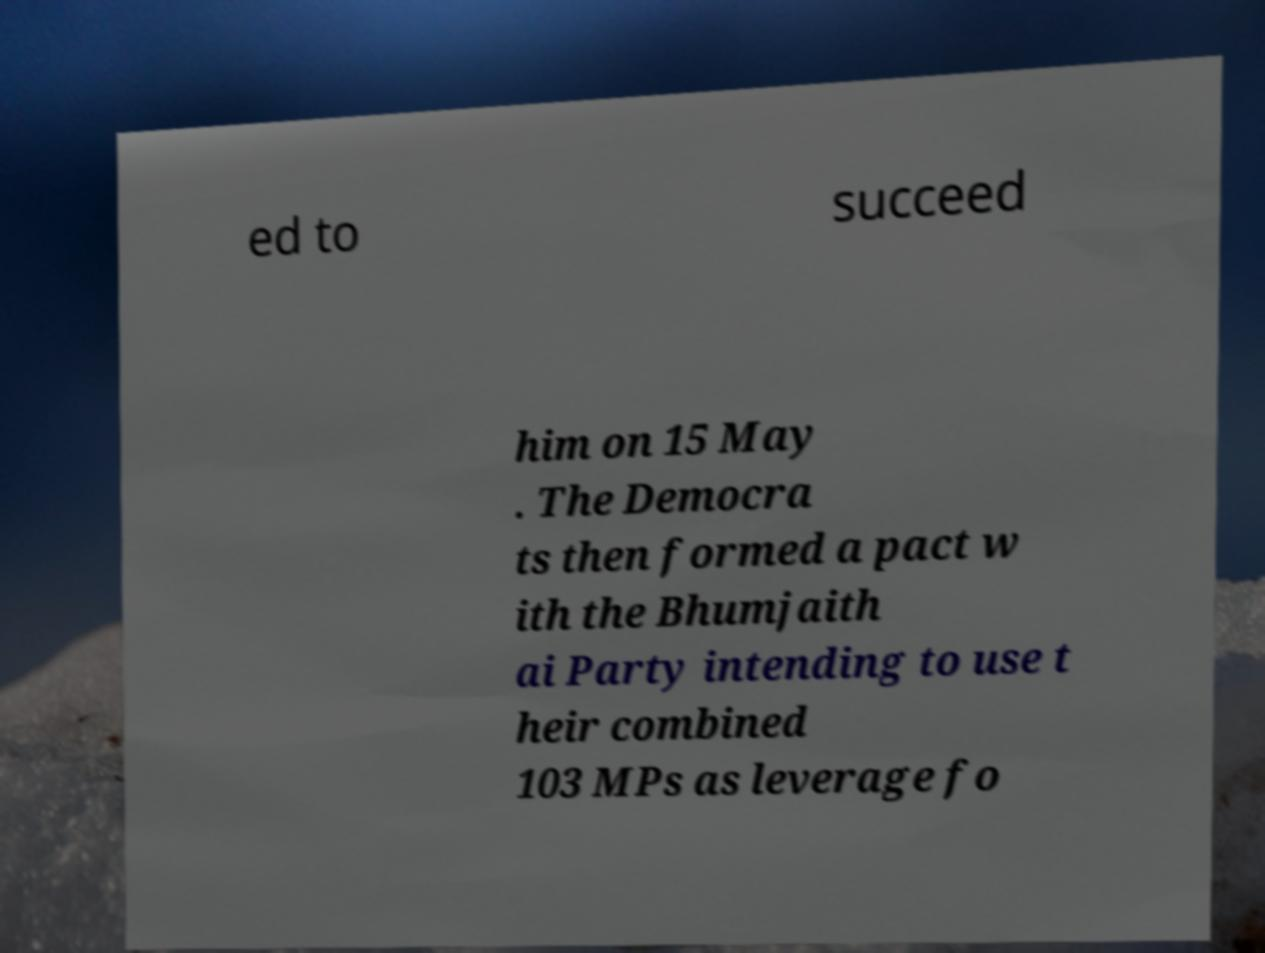There's text embedded in this image that I need extracted. Can you transcribe it verbatim? ed to succeed him on 15 May . The Democra ts then formed a pact w ith the Bhumjaith ai Party intending to use t heir combined 103 MPs as leverage fo 